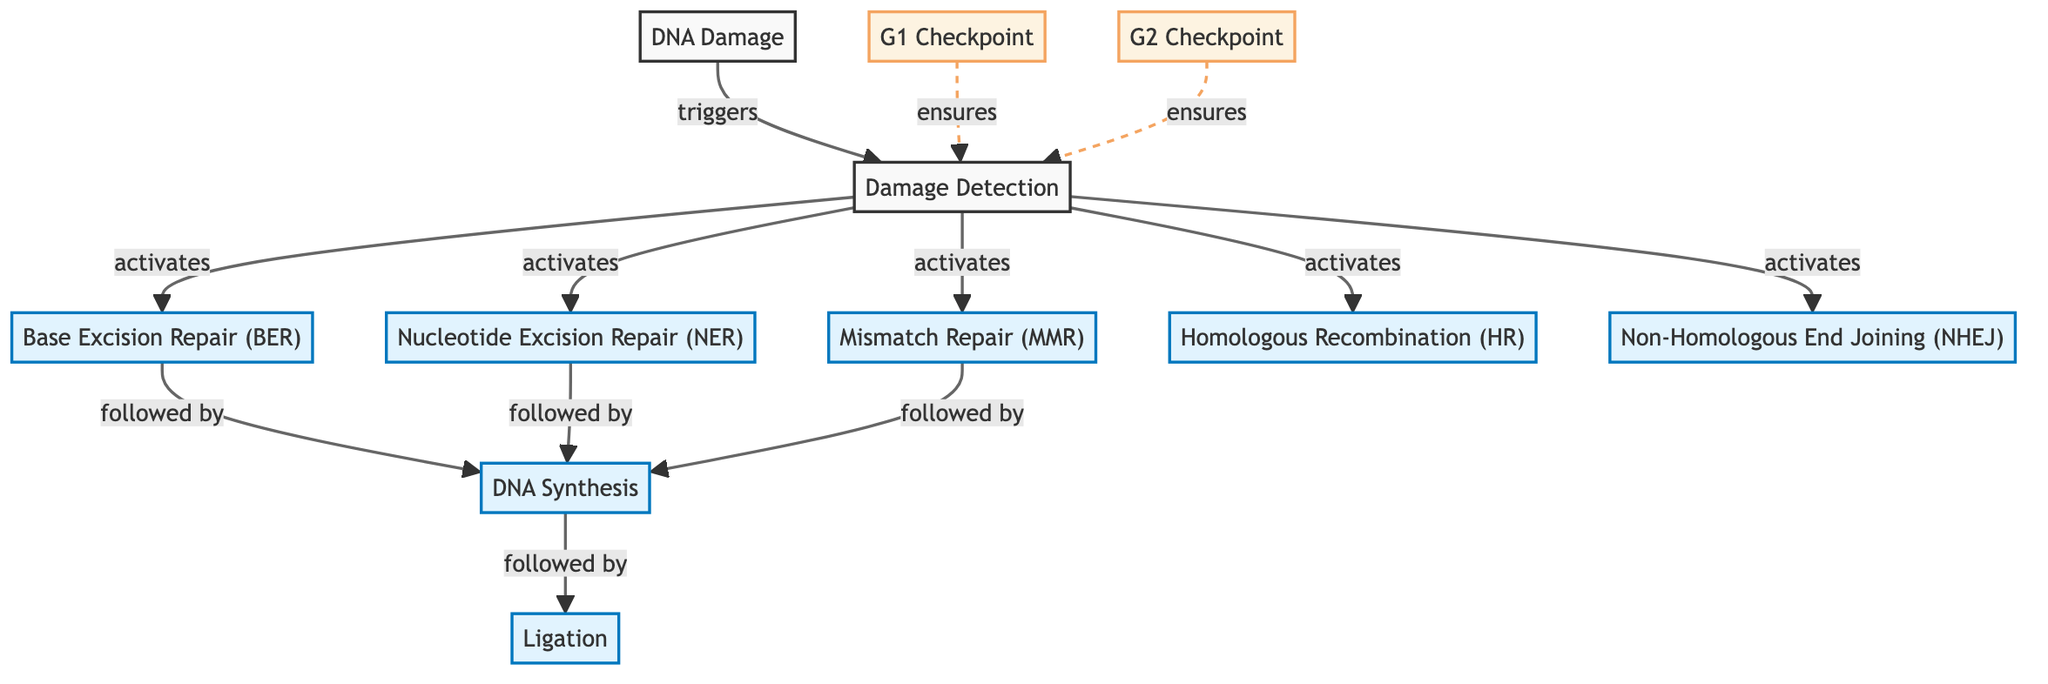What initiates DNA repair mechanisms in the diagram? The diagram indicates that "DNA Damage" triggers "Damage Detection," which is the starting point of the repair mechanisms shown.
Answer: DNA Damage How many DNA repair pathways are activated upon damage detection? The diagram shows that "Damage Detection" activates five repair pathways: Base Excision Repair, Nucleotide Excision Repair, Mismatch Repair, Homologous Recombination, and Non-Homologous End Joining. Thus, there are five pathways.
Answer: 5 What follows after Base Excision Repair in the diagram? According to the diagram, after Base Excision Repair, the next step is "DNA Synthesis." This relationship is illustrated by the arrow connecting the two nodes.
Answer: DNA Synthesis Which checkpoints ensure damage detection in the repair mechanisms? The diagram illustrates that both the "G1 Checkpoint" and "G2 Checkpoint" ensure "Damage Detection," as indicated by the dashed connections leading to Detection.
Answer: G1 Checkpoint and G2 Checkpoint What is the final step in the DNA repair process as per the diagram? The last step depicted in the diagram after DNA Synthesis is "Ligation," indicating that after synthesizing new DNA strands, they are connected or ligated.
Answer: Ligation Which DNA repair mechanism is not directly followed by another step? The diagram shows that Nucleotide Excision Repair, Mismatch Repair, Homologous Recombination, and Non-Homologous End Joining are all followed by DNA Synthesis, but "DNA Damage" itself does not lead to a subsequent step. Therefore, it is the only one not directly followed by another step.
Answer: DNA Damage Describe the flow from DNA Damage to Ligation. The flow begins with DNA Damage, which triggers Detection. From Detection, various repair mechanisms are activated, including Base Excision Repair, which leads to DNA Synthesis. After DNA Synthesis, the pathway proceeds to Ligation as the final step. Hence, every stage logically leads to the next until reaching Ligation.
Answer: DNA Damage → Detection → [Various Repair Pathways] → DNA Synthesis → Ligation Which repair pathways are categorized as processes in the diagram? The diagram distinguishes sections by class, and the process pathways include Base Excision Repair, Nucleotide Excision Repair, Mismatch Repair, Homologous Recombination, and Non-Homologous End Joining, all identified under the process class.
Answer: Base Excision Repair, Nucleotide Excision Repair, Mismatch Repair, Homologous Recombination, Non-Homologous End Joining 